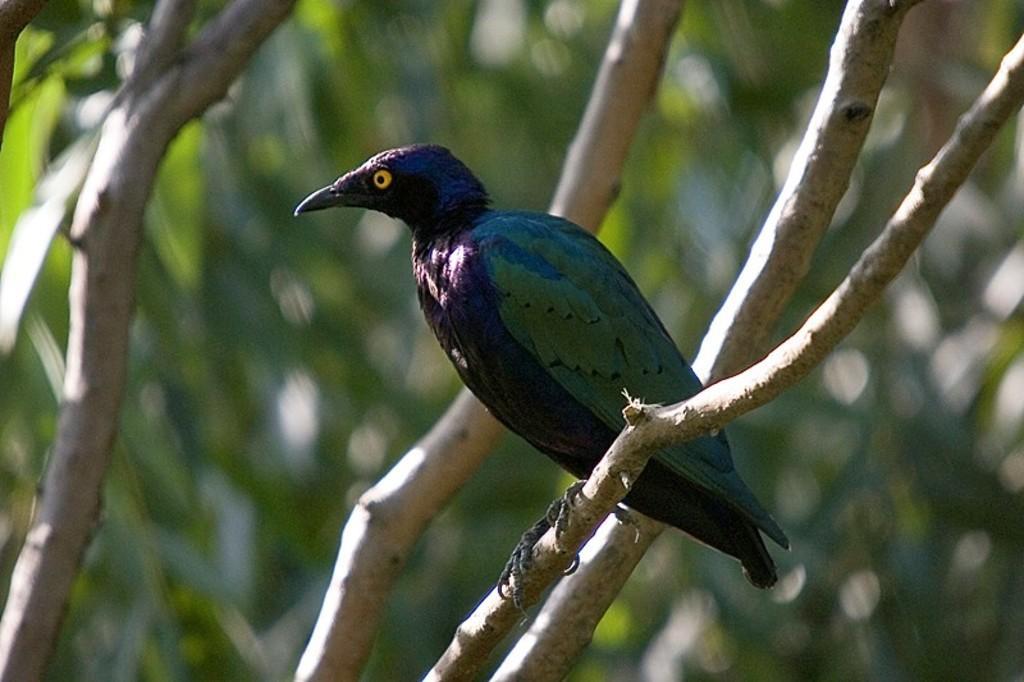Please provide a concise description of this image. Here in this picture we can see a bird represent on the branch of the tree over there. 